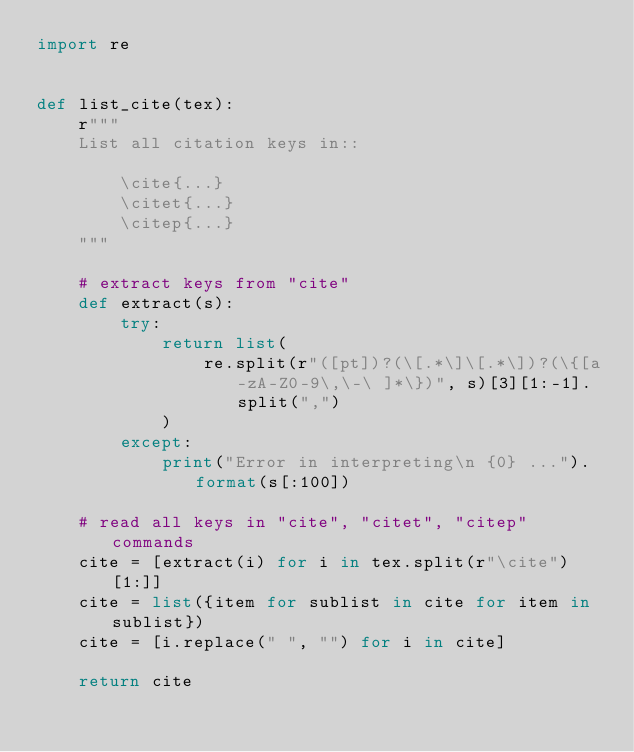Convert code to text. <code><loc_0><loc_0><loc_500><loc_500><_Python_>import re


def list_cite(tex):
    r"""
    List all citation keys in::

        \cite{...}
        \citet{...}
        \citep{...}
    """

    # extract keys from "cite"
    def extract(s):
        try:
            return list(
                re.split(r"([pt])?(\[.*\]\[.*\])?(\{[a-zA-Z0-9\,\-\ ]*\})", s)[3][1:-1].split(",")
            )
        except:
            print("Error in interpreting\n {0} ...").format(s[:100])

    # read all keys in "cite", "citet", "citep" commands
    cite = [extract(i) for i in tex.split(r"\cite")[1:]]
    cite = list({item for sublist in cite for item in sublist})
    cite = [i.replace(" ", "") for i in cite]

    return cite
</code> 